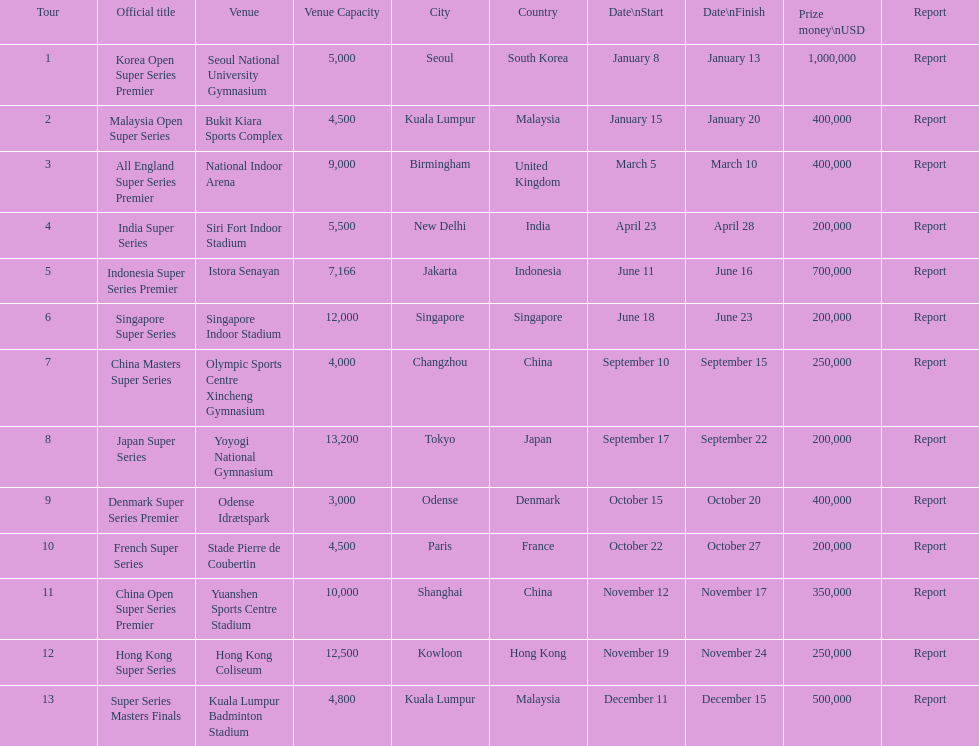Which series provides the highest cash prize? Korea Open Super Series Premier. 